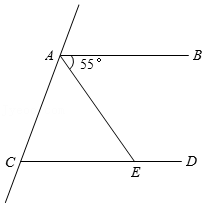What can be said about the angle relationships in this diagram? The diagram includes parallel lines AB and CD, which are intersected by a transversal. According to the corresponding angles postulate, certain angles are equal. The explicit 55° angle at point A suggests that the corresponding angle at point E would also be 55° if extended, illustrating properties of parallel lines intersected by a transversal. 